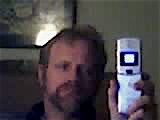Describe the objects in this image and their specific colors. I can see people in black and brown tones and cell phone in black, darkgray, lavender, and lightblue tones in this image. 